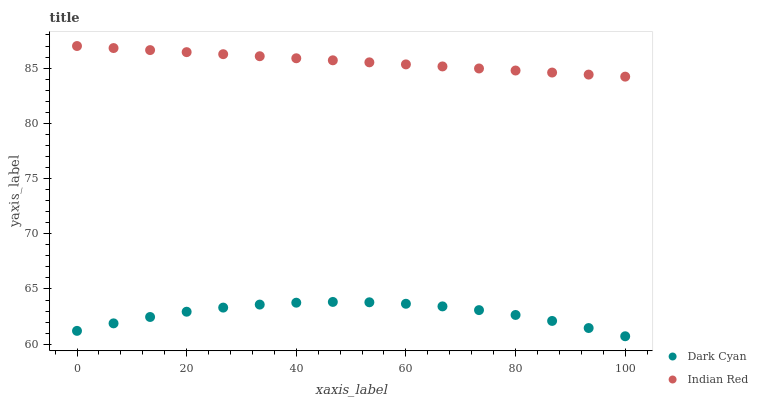Does Dark Cyan have the minimum area under the curve?
Answer yes or no. Yes. Does Indian Red have the maximum area under the curve?
Answer yes or no. Yes. Does Indian Red have the minimum area under the curve?
Answer yes or no. No. Is Indian Red the smoothest?
Answer yes or no. Yes. Is Dark Cyan the roughest?
Answer yes or no. Yes. Is Indian Red the roughest?
Answer yes or no. No. Does Dark Cyan have the lowest value?
Answer yes or no. Yes. Does Indian Red have the lowest value?
Answer yes or no. No. Does Indian Red have the highest value?
Answer yes or no. Yes. Is Dark Cyan less than Indian Red?
Answer yes or no. Yes. Is Indian Red greater than Dark Cyan?
Answer yes or no. Yes. Does Dark Cyan intersect Indian Red?
Answer yes or no. No. 